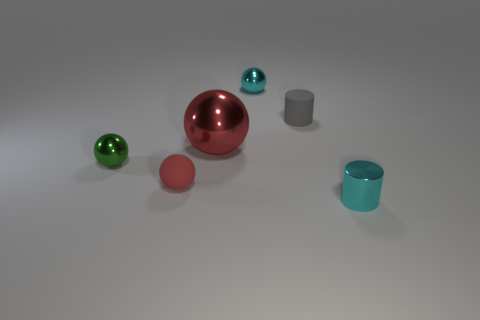How many cylinders are either big brown matte things or green metallic things?
Your response must be concise. 0. There is a small shiny sphere left of the small shiny ball to the right of the small green metal object; what number of metallic balls are on the right side of it?
Keep it short and to the point. 2. What material is the tiny object that is the same color as the shiny cylinder?
Your answer should be very brief. Metal. Is the number of red rubber spheres greater than the number of small shiny spheres?
Your response must be concise. No. Is the green shiny sphere the same size as the cyan shiny ball?
Your answer should be compact. Yes. How many objects are either big red metallic things or blue matte spheres?
Your response must be concise. 1. There is a cyan thing to the right of the cylinder that is behind the tiny cylinder that is in front of the red metal sphere; what shape is it?
Your answer should be compact. Cylinder. Are the cylinder that is behind the small green metallic object and the small sphere in front of the small green metallic thing made of the same material?
Make the answer very short. Yes. What is the material of the big red thing that is the same shape as the small green shiny object?
Make the answer very short. Metal. Is there any other thing that has the same size as the cyan shiny cylinder?
Make the answer very short. Yes. 